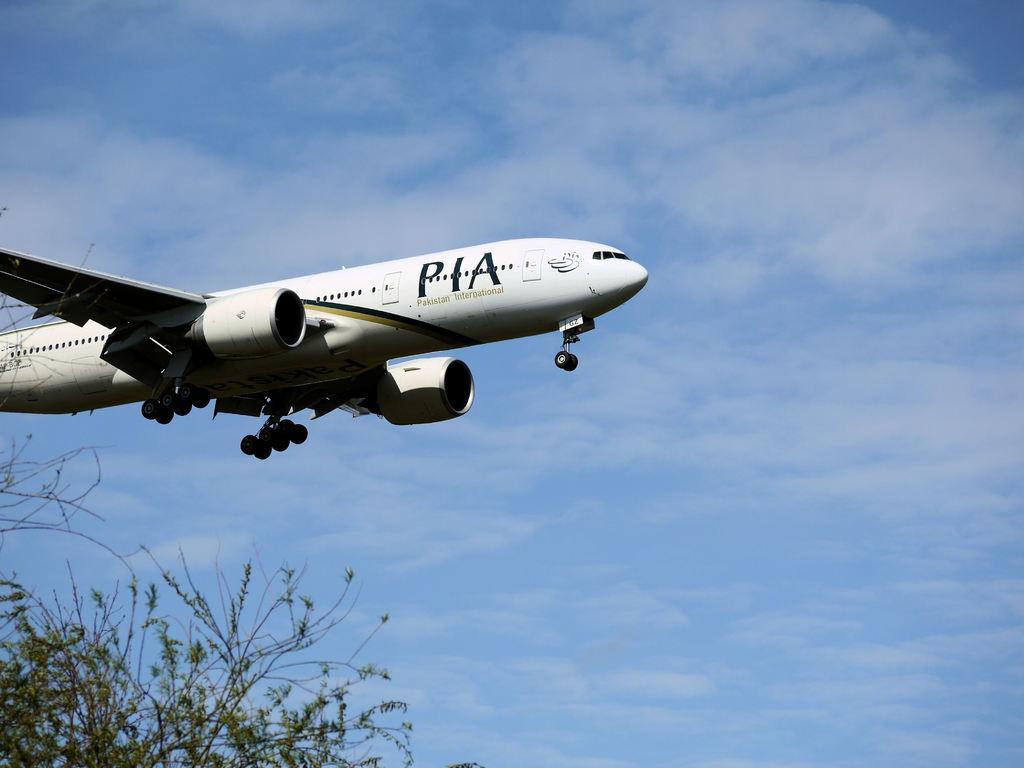Describe this image in one or two sentences. In the middle of the image, we can see an airplane is flying in the air. In the bottom left corner of the image, we can see leaves and stems. In the background, there is the sky. 